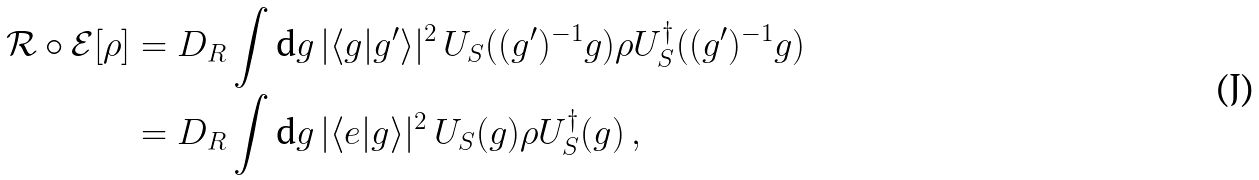<formula> <loc_0><loc_0><loc_500><loc_500>\mathcal { R } \circ \mathcal { E } [ \rho ] & = D _ { R } \int \text {d} g \, | \langle g | g ^ { \prime } \rangle | ^ { 2 } \, U _ { S } ( ( g ^ { \prime } ) ^ { - 1 } g ) \rho U _ { S } ^ { \dag } ( ( g ^ { \prime } ) ^ { - 1 } g ) \\ & = D _ { R } \int \text {d} g \, | \langle e | g \rangle | ^ { 2 } \, U _ { S } ( g ) \rho U _ { S } ^ { \dag } ( g ) \, ,</formula> 